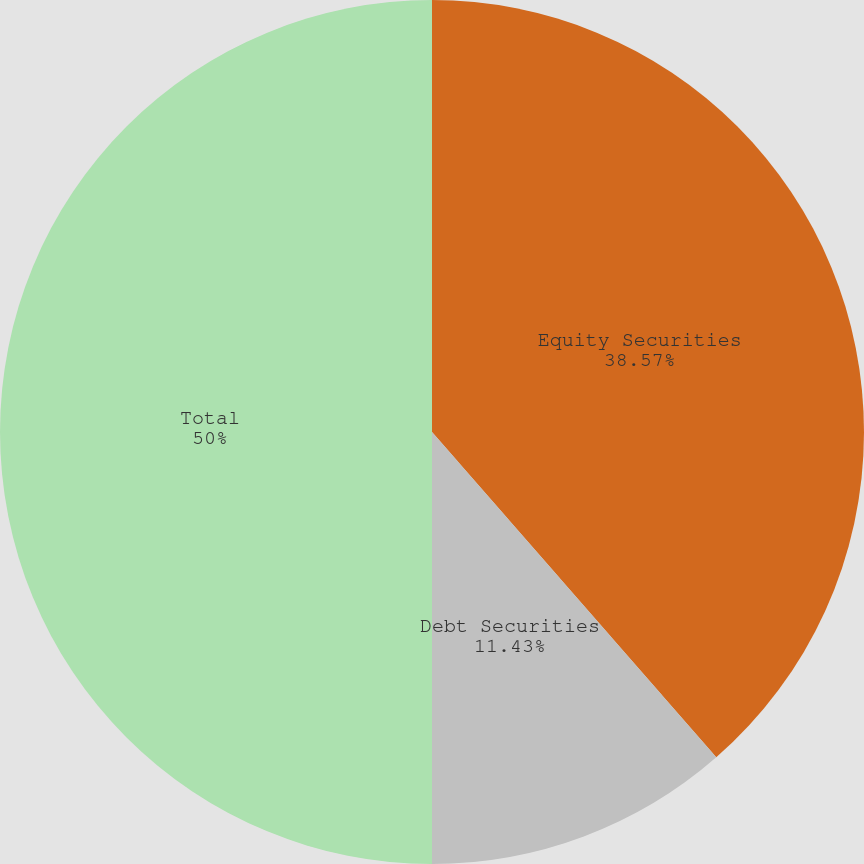<chart> <loc_0><loc_0><loc_500><loc_500><pie_chart><fcel>Equity Securities<fcel>Debt Securities<fcel>Total<nl><fcel>38.57%<fcel>11.43%<fcel>50.0%<nl></chart> 